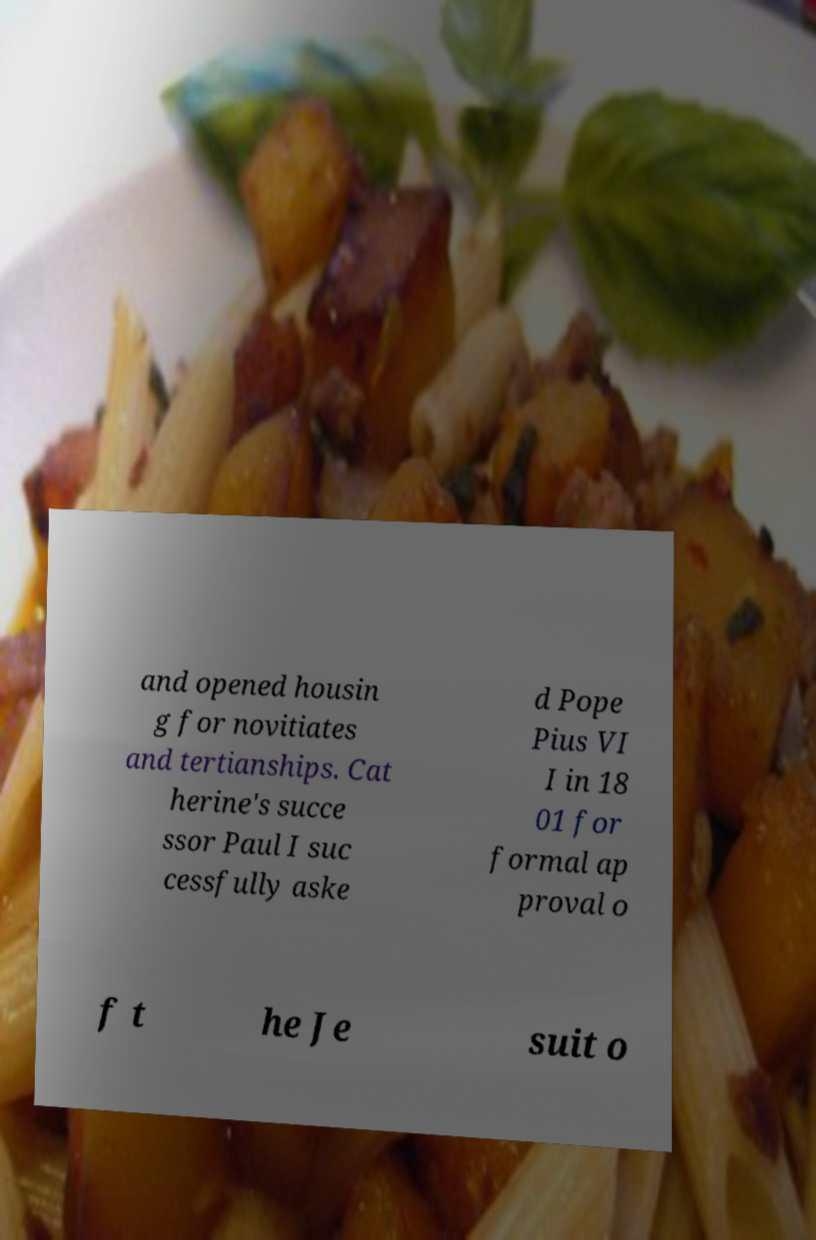There's text embedded in this image that I need extracted. Can you transcribe it verbatim? and opened housin g for novitiates and tertianships. Cat herine's succe ssor Paul I suc cessfully aske d Pope Pius VI I in 18 01 for formal ap proval o f t he Je suit o 